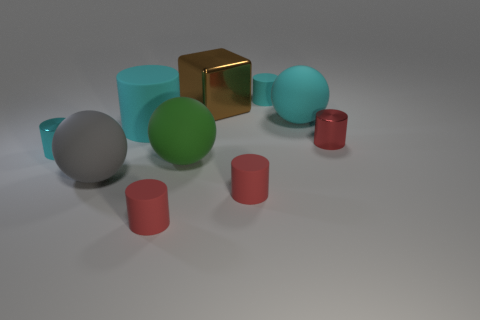Does the block that is behind the green matte object have the same size as the large cylinder?
Make the answer very short. Yes. Is there anything else that is the same size as the cyan metal object?
Your response must be concise. Yes. There is a cyan metal thing that is the same shape as the tiny red shiny thing; what size is it?
Give a very brief answer. Small. Are there the same number of big gray objects right of the gray ball and metal cylinders that are behind the large brown cube?
Offer a terse response. Yes. There is a metal object that is behind the big matte cylinder; what is its size?
Ensure brevity in your answer.  Large. Do the large cube and the large rubber cylinder have the same color?
Ensure brevity in your answer.  No. Is there anything else that is the same shape as the brown thing?
Provide a short and direct response. No. What material is the ball that is the same color as the large rubber cylinder?
Ensure brevity in your answer.  Rubber. Are there an equal number of red metal cylinders that are right of the cyan sphere and big shiny objects?
Your answer should be very brief. Yes. Are there any red matte things on the right side of the small cyan metallic cylinder?
Keep it short and to the point. Yes. 